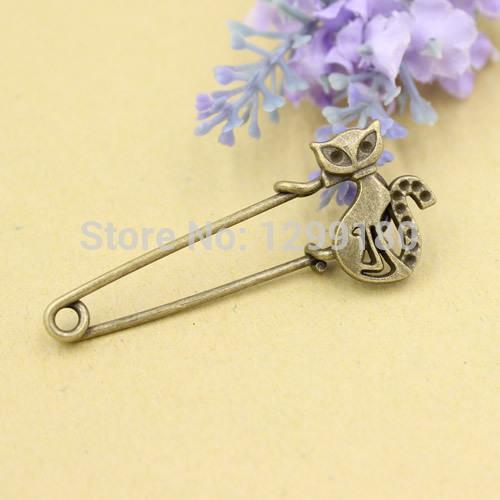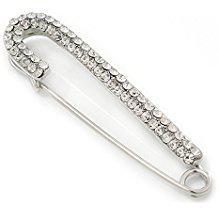The first image is the image on the left, the second image is the image on the right. For the images shown, is this caption "There is an animal on one of the clips." true? Answer yes or no. Yes. 